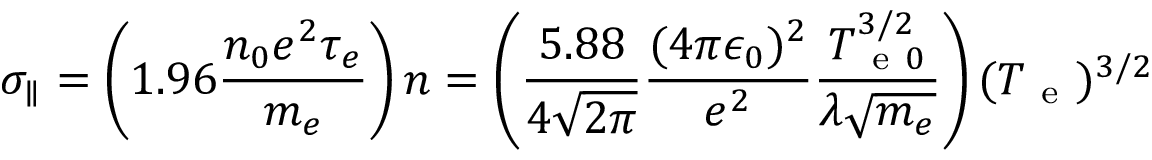Convert formula to latex. <formula><loc_0><loc_0><loc_500><loc_500>\sigma _ { \| } = \left ( 1 . 9 6 \frac { n _ { 0 } e ^ { 2 } \tau _ { e } } { m _ { e } } \right ) n = \left ( \frac { 5 . 8 8 } { 4 \sqrt { 2 \pi } } \frac { ( 4 \pi \epsilon _ { 0 } ) ^ { 2 } } { e ^ { 2 } } \frac { T _ { e 0 } ^ { 3 / 2 } } { \lambda \sqrt { m _ { e } } } \right ) ( T _ { e } ) ^ { 3 / 2 }</formula> 